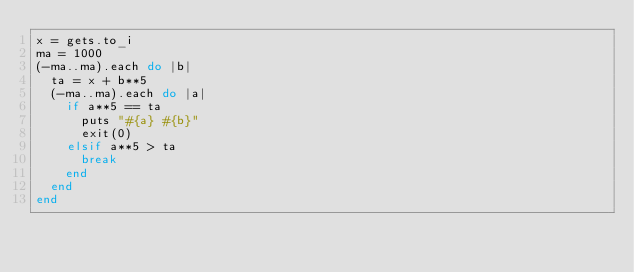<code> <loc_0><loc_0><loc_500><loc_500><_Ruby_>x = gets.to_i
ma = 1000
(-ma..ma).each do |b|
  ta = x + b**5
  (-ma..ma).each do |a|
    if a**5 == ta
      puts "#{a} #{b}"
      exit(0)
    elsif a**5 > ta
      break
    end
  end
end
    </code> 